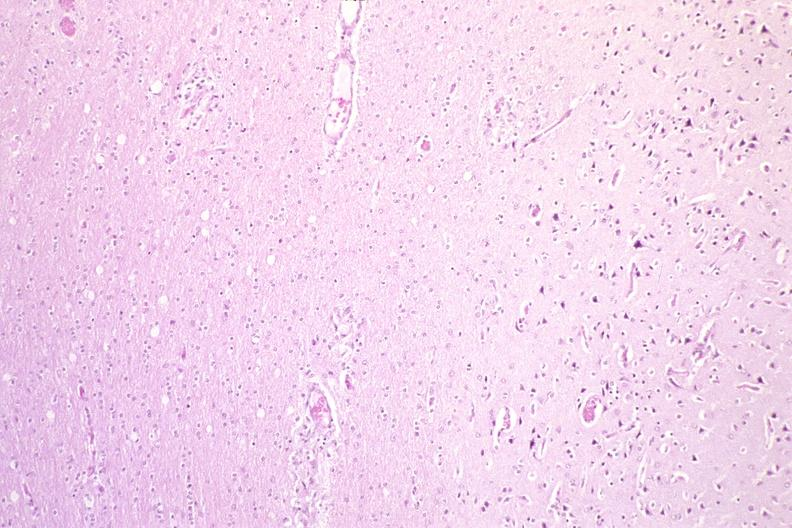does retroperitoneum show brain, hiv neuropathy?
Answer the question using a single word or phrase. No 